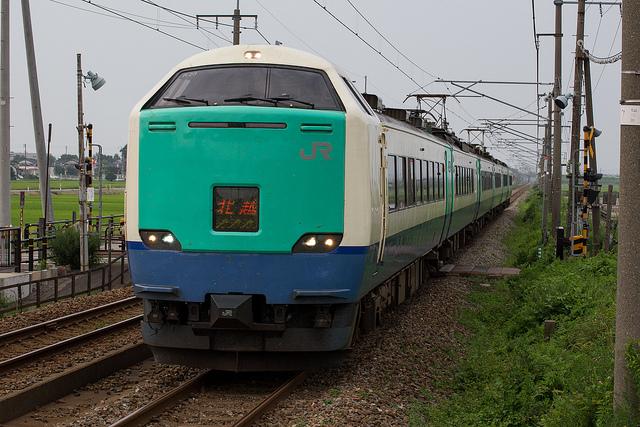What color is the front of the train?
Write a very short answer. Green. Is the train moving toward the camera?
Give a very brief answer. Yes. Where was this photo taken?
Be succinct. Tracks. What color is the train?
Be succinct. Green. Where is the train going?
Answer briefly. South. Is the train at the station?
Keep it brief. No. Is this a passenger train?
Write a very short answer. Yes. How many headlights are on?
Answer briefly. 4. What color is the light on the left?
Concise answer only. White. Where is this train going?
Quick response, please. City. 